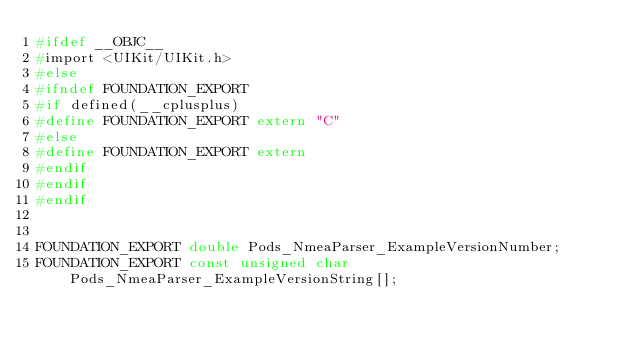<code> <loc_0><loc_0><loc_500><loc_500><_C_>#ifdef __OBJC__
#import <UIKit/UIKit.h>
#else
#ifndef FOUNDATION_EXPORT
#if defined(__cplusplus)
#define FOUNDATION_EXPORT extern "C"
#else
#define FOUNDATION_EXPORT extern
#endif
#endif
#endif


FOUNDATION_EXPORT double Pods_NmeaParser_ExampleVersionNumber;
FOUNDATION_EXPORT const unsigned char Pods_NmeaParser_ExampleVersionString[];

</code> 